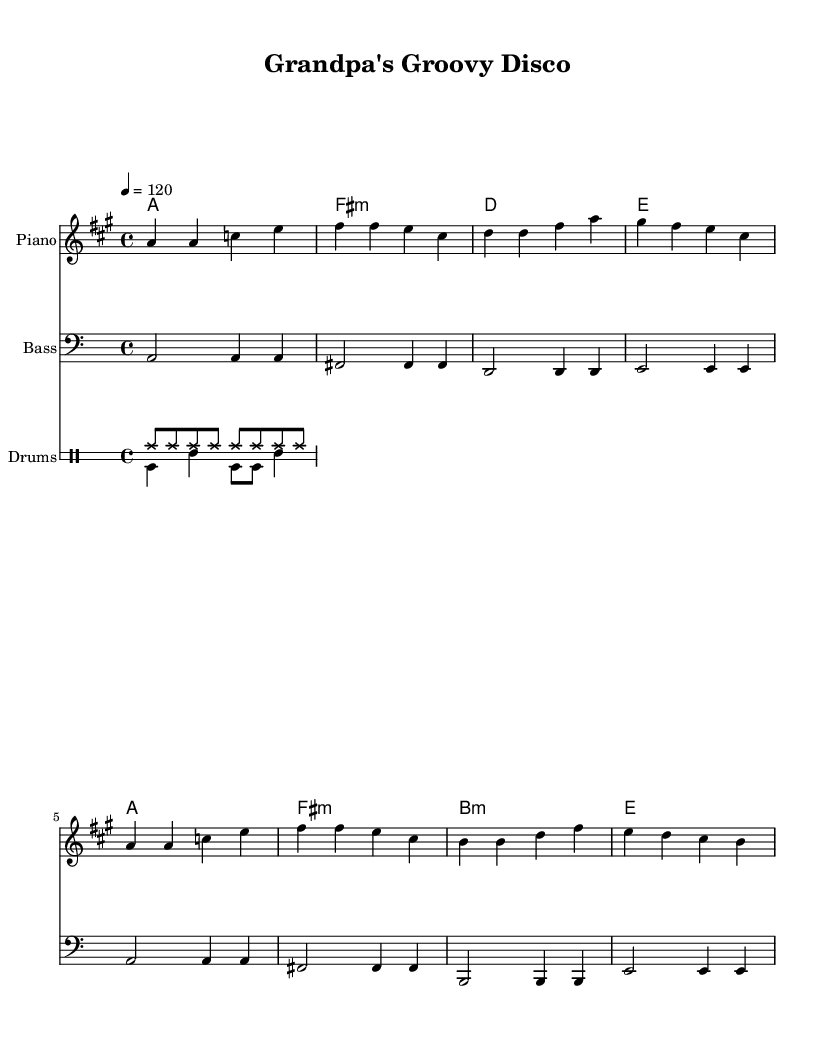What is the key signature of this music? The key signature is A major, which has three sharps (F#, C#, and G#). It can be identified by looking at the key signature at the beginning of the staff.
Answer: A major What is the time signature of the piece? The time signature is 4/4, indicated by the notation at the beginning of the score. Each measure has four beats, and the quarter note gets one beat.
Answer: 4/4 What is the tempo marking for the music? The tempo marking indicates the piece is played at a speed of 120 beats per minute. This is noted as "4 = 120" at the top of the score.
Answer: 120 How many measures are in the melody? To find the total number of measures in the melody, count the number of separated sections in the melody line. There are eight distinct measures.
Answer: 8 What instrument is indicated for the harmony part? The harmony part is indicated for the Piano, as shown under the heading of "instrumentName" in the corresponding staff.
Answer: Piano What type of music is this piece classified as? This piece is classified as Dance music. The upbeat tempo and rhythmic patterns typical of disco hits from the 1970s indicate its genre.
Answer: Dance 